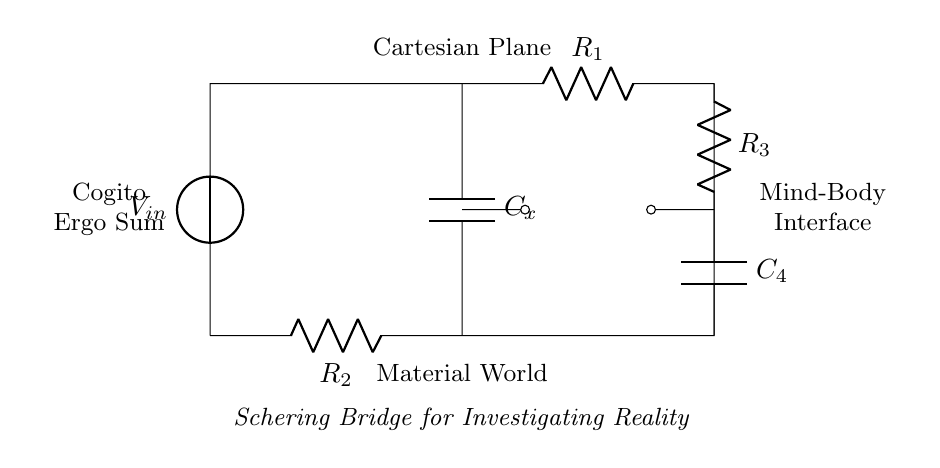What components are in the Schering bridge? The circuit includes a voltage source, two resistors, and two capacitors interconnected in a bridge configuration.
Answer: Voltage source, resistors, capacitors What is the purpose of the component labeled Cx? Cx is the key capacitor being measured, which allows the investigation of its properties such as capacitance in the context of the bridge.
Answer: Measure capacitance Which components correspond to the mind-body interface in the circuit? The resistors R3 and C4 form the components representing the mind-body interface, indicating the connection between different aspects of the system.
Answer: R3 and C4 What is the significance of R1 and R2 in this bridge circuit? R1 and R2 provide reference values that help balance the bridge, allowing for precise measurements of reactive components like capacitors.
Answer: Balance and reference How can one determine the balance condition in the Schering bridge? The balance condition can be determined when the ratio of R1 to R2 equals the ratio of C4 to Cx, allowing no current to flow through the measurement path.
Answer: Ratio equality 